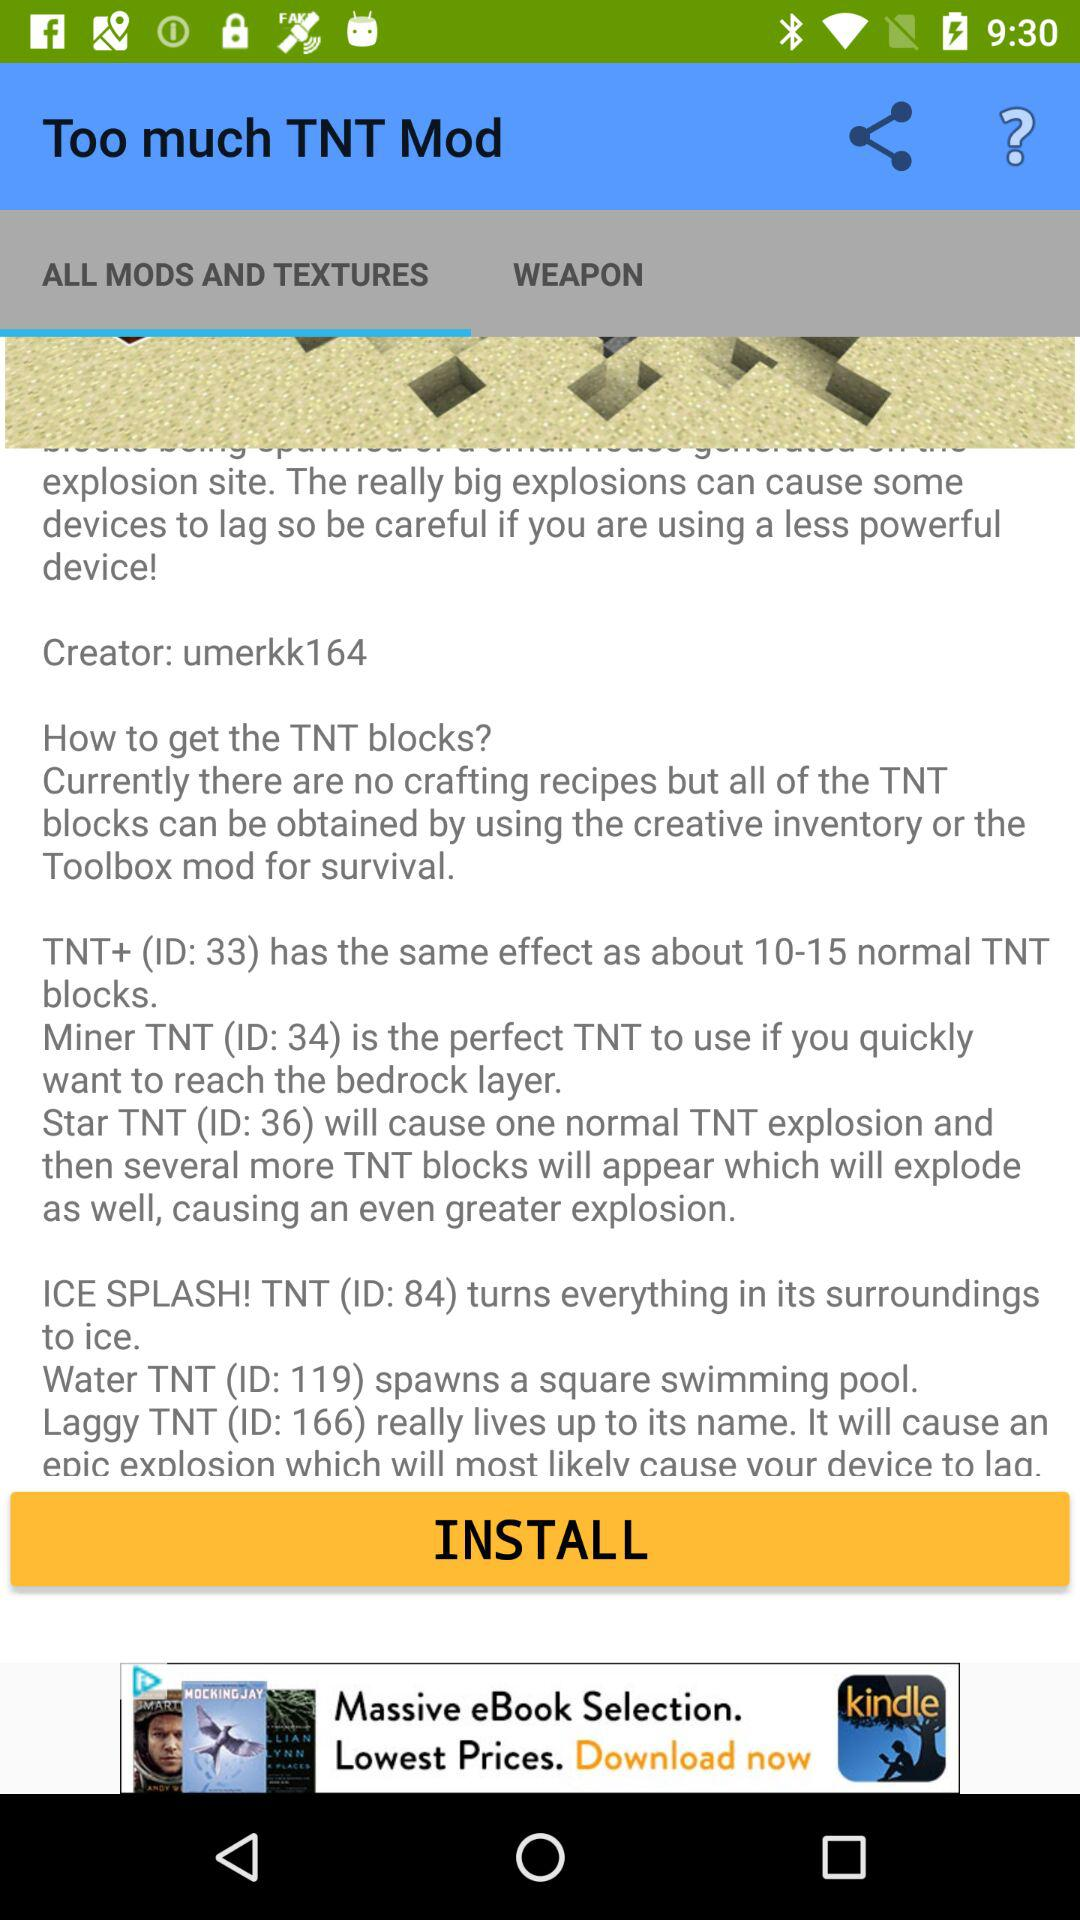Who is the creator? The creator is "umerkk164". 